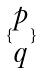<formula> <loc_0><loc_0><loc_500><loc_500>\{ \begin{matrix} p \\ q \end{matrix} \}</formula> 